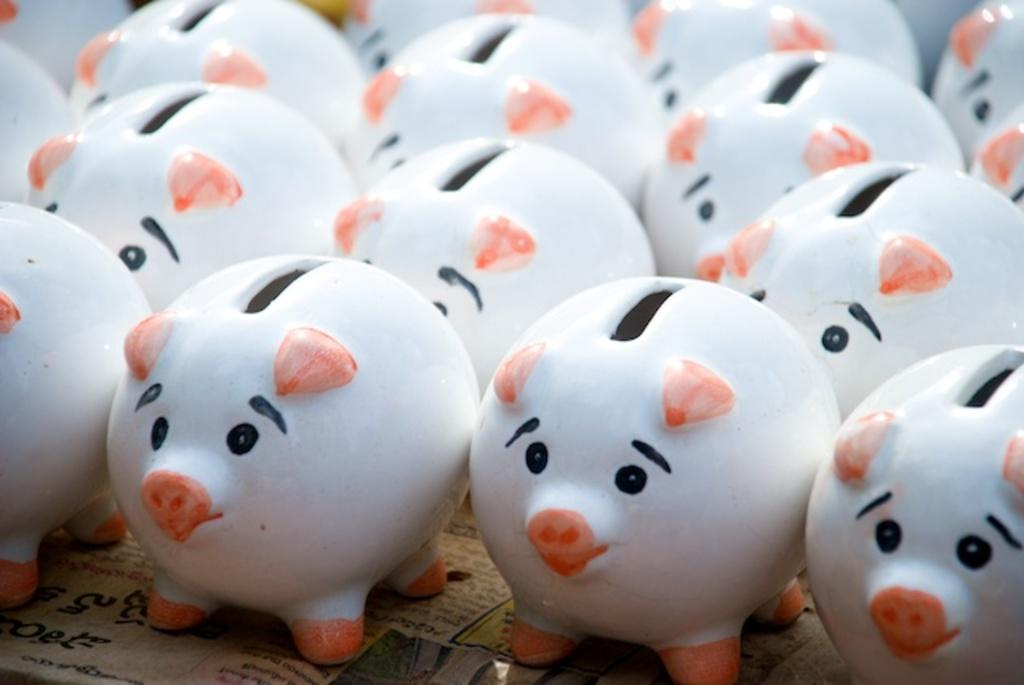What objects are present in the image? There are piggy-banks in the image. What colors can be seen on the piggy-banks? The piggy-banks are in white, orange, and black colors. What is the piggy-banks placed on? The piggy-banks are on a newspaper. What type of hen can be seen sitting on the pot in the image? There is no hen or pot present in the image; it only features piggy-banks on a newspaper. 